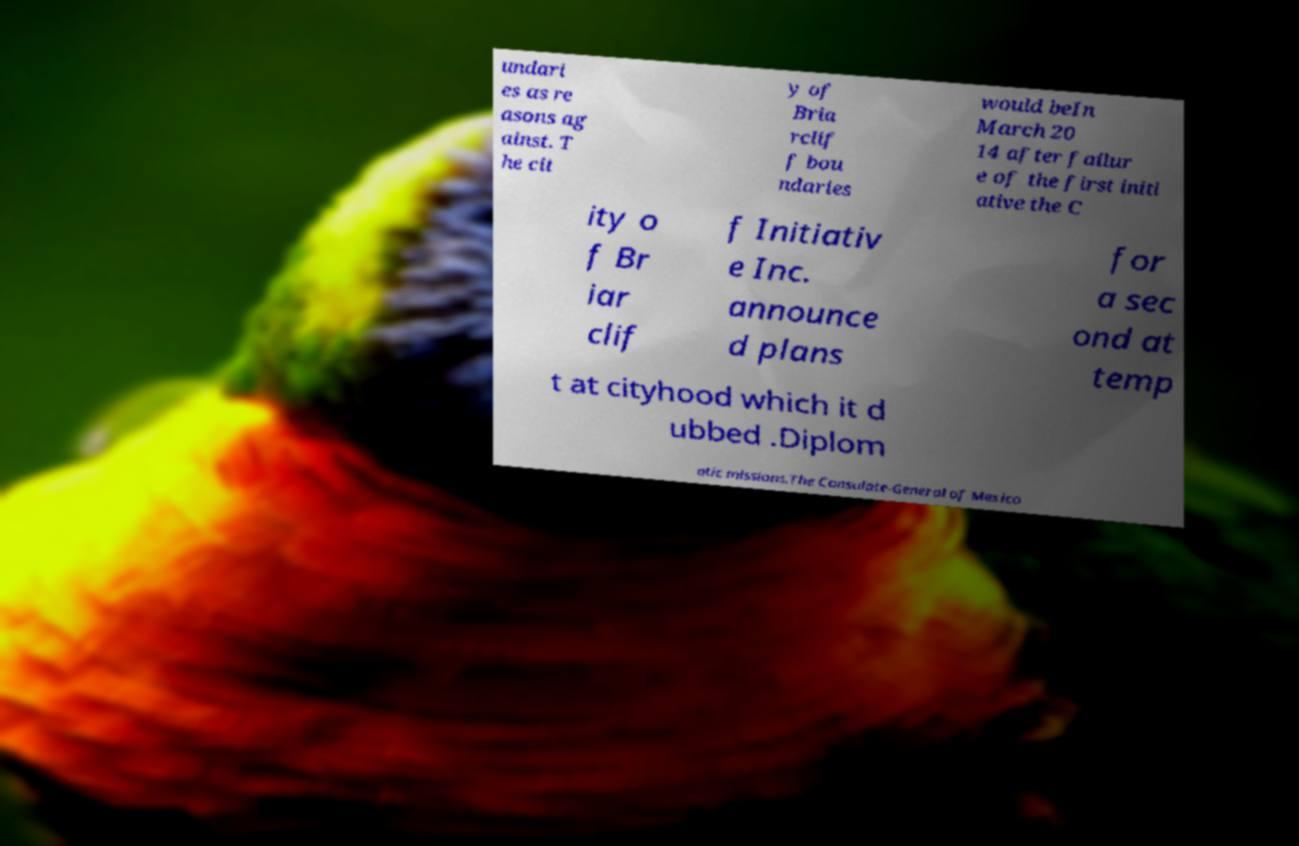I need the written content from this picture converted into text. Can you do that? undari es as re asons ag ainst. T he cit y of Bria rclif f bou ndaries would beIn March 20 14 after failur e of the first initi ative the C ity o f Br iar clif f Initiativ e Inc. announce d plans for a sec ond at temp t at cityhood which it d ubbed .Diplom atic missions.The Consulate-General of Mexico 